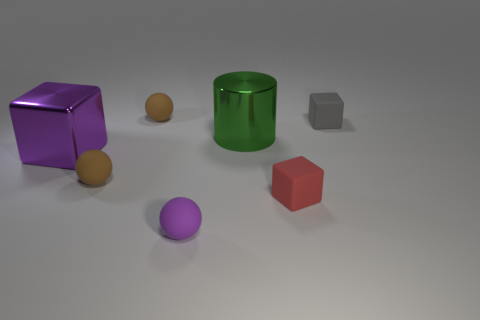There is a small thing that is the same color as the metallic cube; what is its shape?
Your response must be concise. Sphere. Is the purple metal object the same shape as the tiny purple object?
Offer a terse response. No. Do the matte ball that is behind the purple shiny cube and the shiny thing that is behind the large purple shiny object have the same size?
Provide a short and direct response. No. What is the material of the cube that is both to the right of the purple metal block and behind the red cube?
Provide a succinct answer. Rubber. Is there any other thing of the same color as the cylinder?
Your answer should be very brief. No. Are there fewer small spheres behind the red matte object than rubber spheres?
Ensure brevity in your answer.  Yes. Is the number of big cylinders greater than the number of gray shiny cubes?
Make the answer very short. Yes. Is there a purple metallic thing in front of the tiny rubber block that is in front of the big shiny object to the right of the purple rubber sphere?
Provide a succinct answer. No. How many other things are the same size as the red matte cube?
Keep it short and to the point. 4. Are there any purple matte balls to the right of the large green cylinder?
Ensure brevity in your answer.  No. 